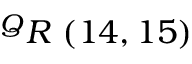<formula> <loc_0><loc_0><loc_500><loc_500>^ { Q } R \ ( 1 4 , 1 5 )</formula> 